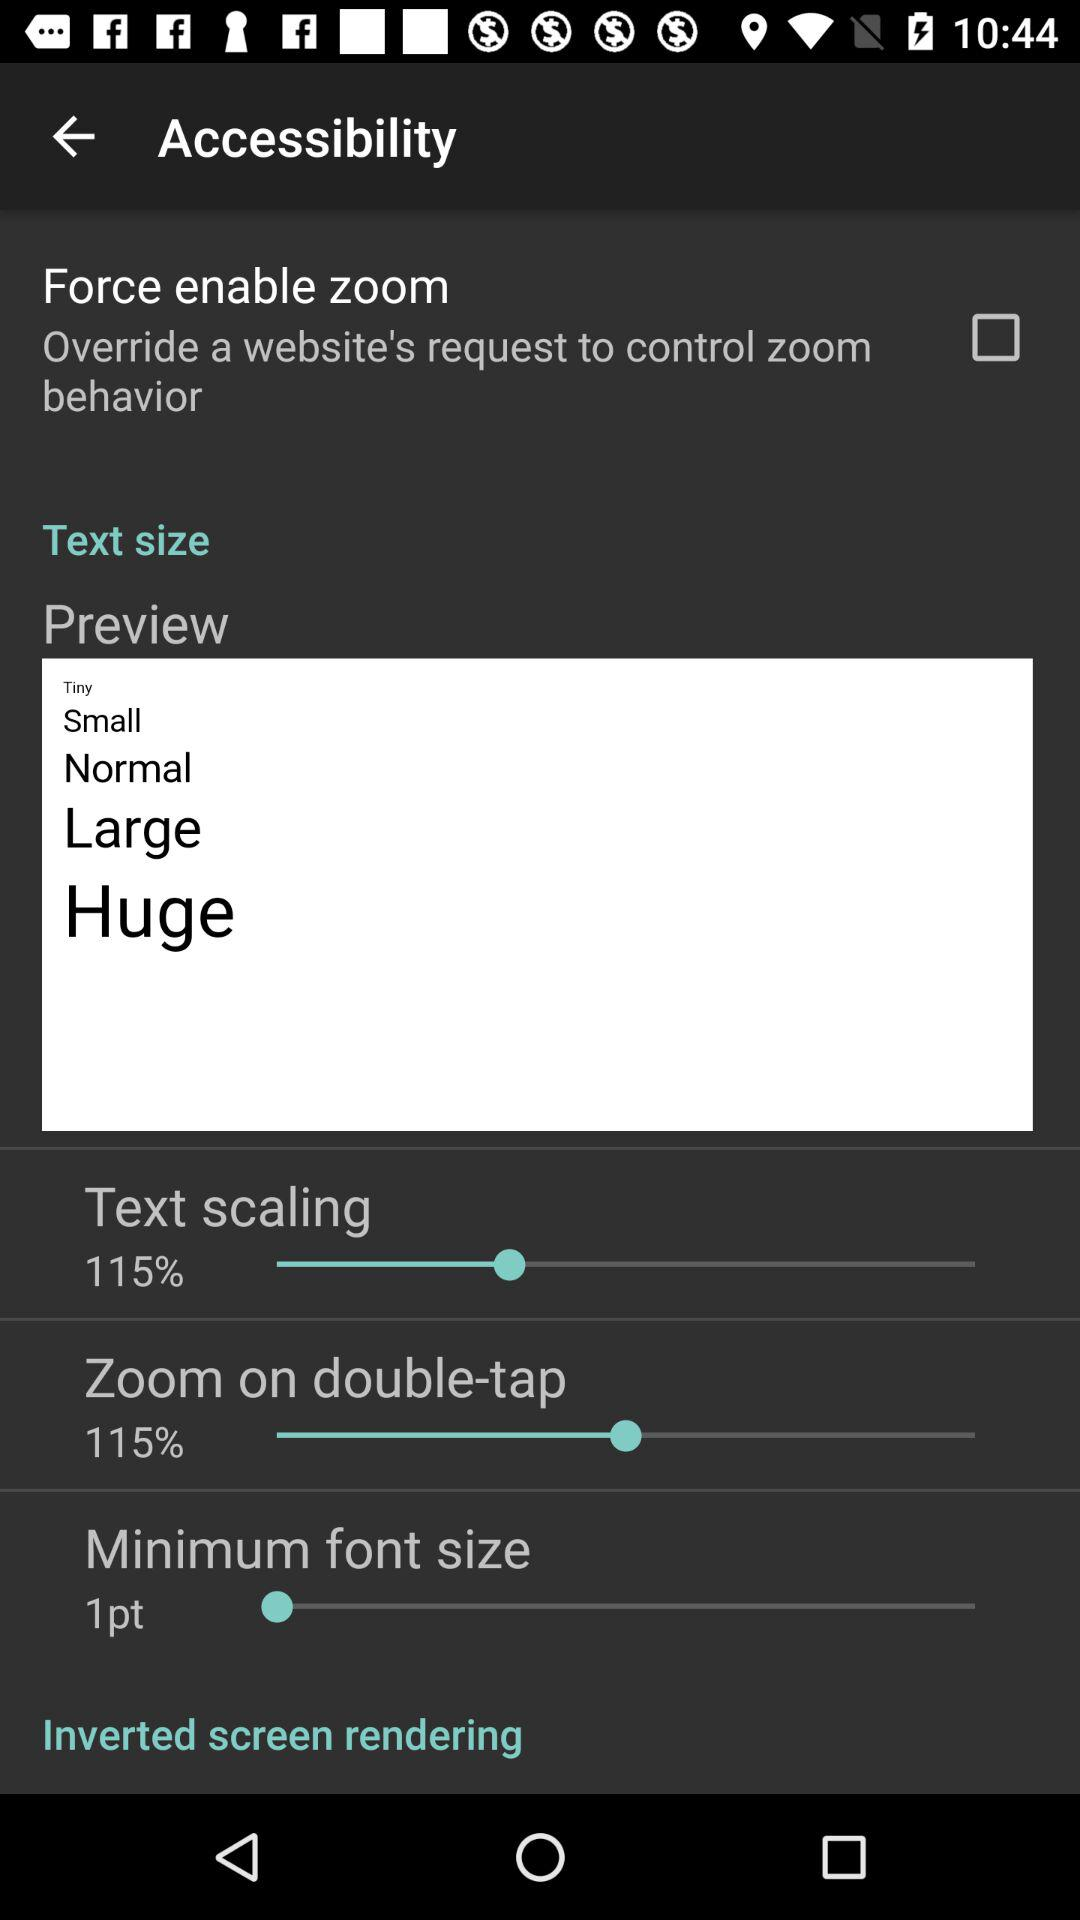Is "Force enable zoom" checked or unchecked?
Answer the question using a single word or phrase. It is unchecked. 